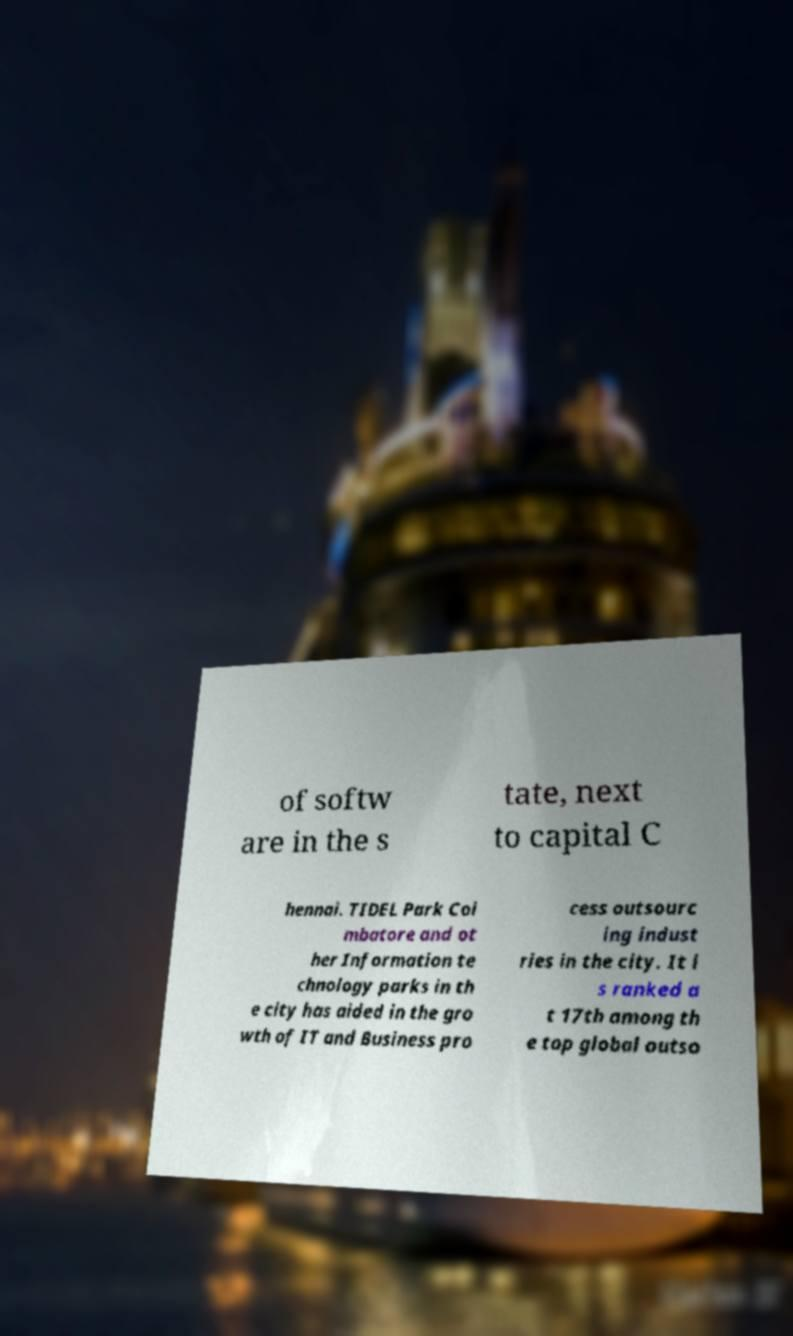I need the written content from this picture converted into text. Can you do that? of softw are in the s tate, next to capital C hennai. TIDEL Park Coi mbatore and ot her Information te chnology parks in th e city has aided in the gro wth of IT and Business pro cess outsourc ing indust ries in the city. It i s ranked a t 17th among th e top global outso 